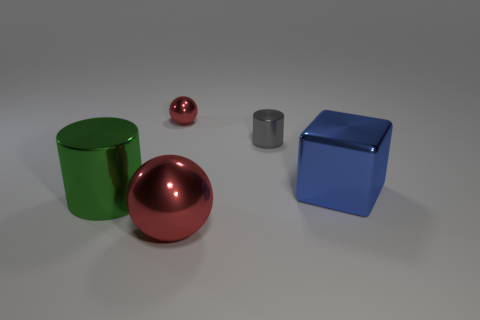There is a small sphere that is the same color as the large sphere; what is it made of?
Your response must be concise. Metal. Is the big red sphere made of the same material as the small red ball?
Offer a terse response. Yes. There is a small red object; are there any blue cubes right of it?
Provide a short and direct response. Yes. The large red object that is right of the red shiny object that is behind the large green thing is made of what material?
Your answer should be very brief. Metal. There is a green thing that is the same shape as the tiny gray object; what is its size?
Keep it short and to the point. Large. Do the small cylinder and the large shiny cylinder have the same color?
Your answer should be very brief. No. There is a big object that is both to the left of the small cylinder and behind the big red shiny thing; what color is it?
Provide a succinct answer. Green. Does the red metal ball that is in front of the gray metal cylinder have the same size as the shiny cube?
Offer a terse response. Yes. Are there any other things that have the same shape as the green object?
Your response must be concise. Yes. Does the big red thing have the same material as the cylinder that is on the left side of the small red sphere?
Give a very brief answer. Yes. 